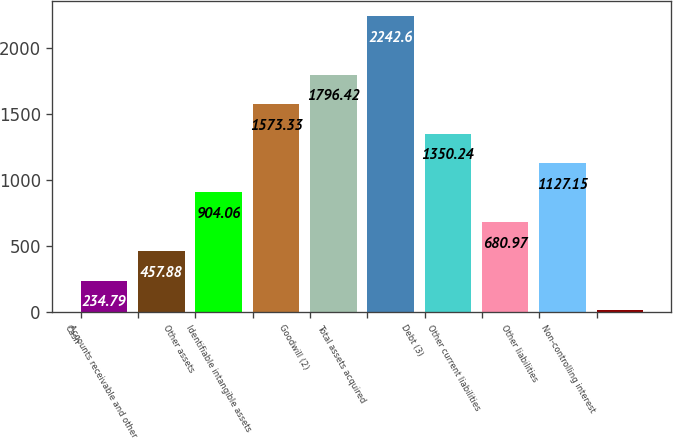Convert chart to OTSL. <chart><loc_0><loc_0><loc_500><loc_500><bar_chart><fcel>Cash<fcel>Accounts receivable and other<fcel>Other assets<fcel>Identifiable intangible assets<fcel>Goodwill (2)<fcel>Total assets acquired<fcel>Debt (3)<fcel>Other current liabilities<fcel>Other liabilities<fcel>Non-controlling interest<nl><fcel>234.79<fcel>457.88<fcel>904.06<fcel>1573.33<fcel>1796.42<fcel>2242.6<fcel>1350.24<fcel>680.97<fcel>1127.15<fcel>11.7<nl></chart> 